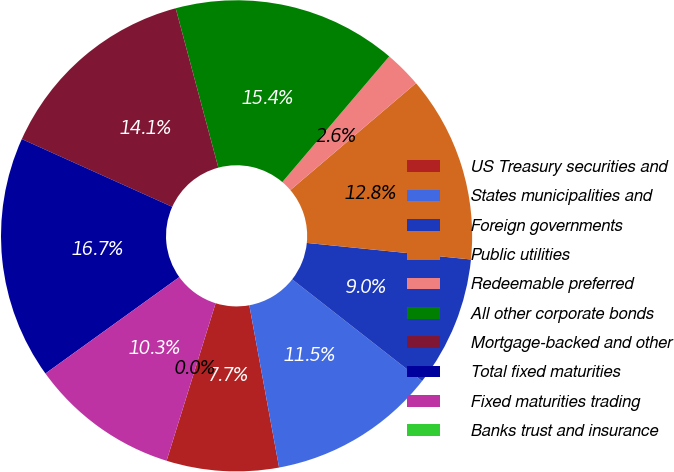<chart> <loc_0><loc_0><loc_500><loc_500><pie_chart><fcel>US Treasury securities and<fcel>States municipalities and<fcel>Foreign governments<fcel>Public utilities<fcel>Redeemable preferred<fcel>All other corporate bonds<fcel>Mortgage-backed and other<fcel>Total fixed maturities<fcel>Fixed maturities trading<fcel>Banks trust and insurance<nl><fcel>7.69%<fcel>11.54%<fcel>8.97%<fcel>12.82%<fcel>2.56%<fcel>15.38%<fcel>14.1%<fcel>16.67%<fcel>10.26%<fcel>0.0%<nl></chart> 